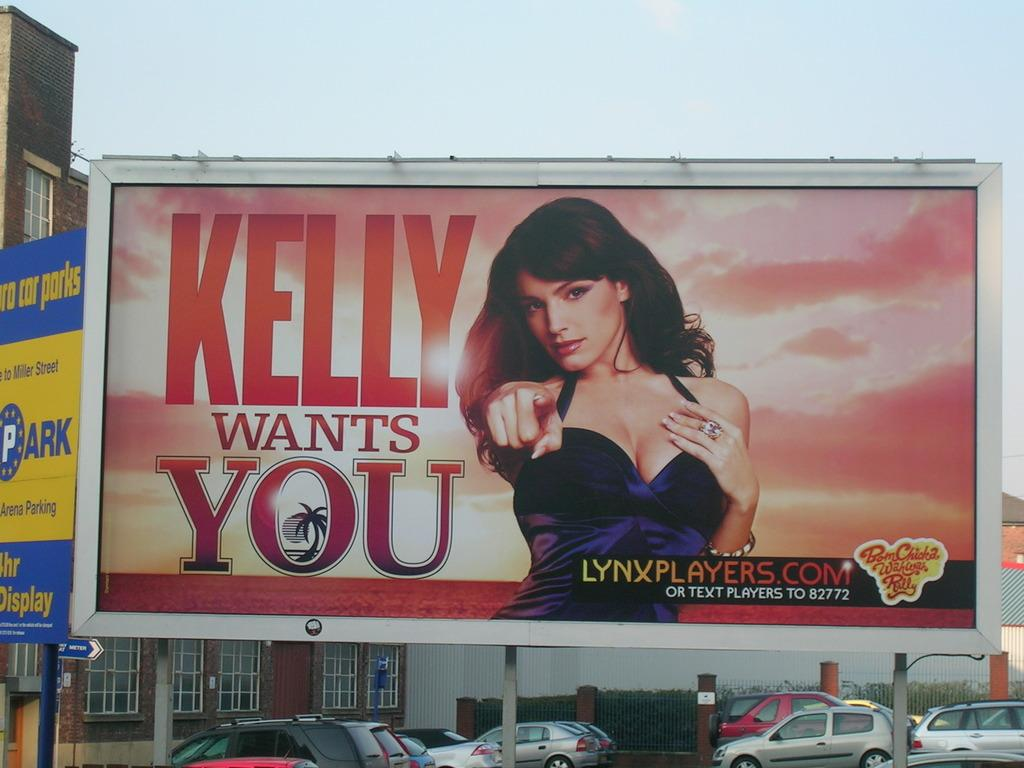<image>
Relay a brief, clear account of the picture shown. A billboard advertisement with the words Kelly Wants You on it. 